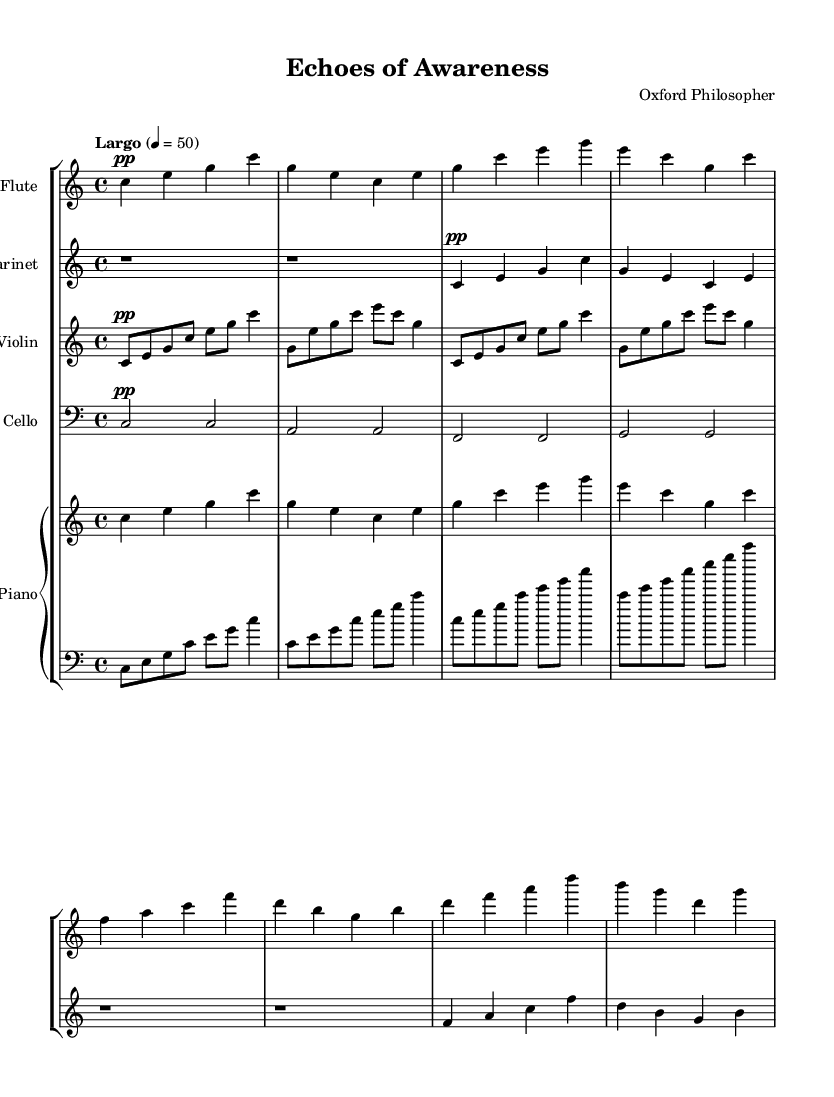What is the key signature of this music? The key signature is C major, which has no sharps or flats.
Answer: C major What is the time signature of this composition? The time signature is indicated at the beginning of the staff as 4/4, meaning there are four beats in each measure and a quarter note gets one beat.
Answer: 4/4 What is the tempo marking of this symphony? The tempo marking shows "Largo," which indicates a slow tempo, typically around 40 to 60 beats per minute. The specific marking states "4 = 50" which tells us the chosen tempo within that range.
Answer: Largo Which instruments are featured in this composition? The instruments included are Flute, Clarinet, Violin, Cello, and Piano (both upper and lower). The score explicitly states each instrument and groups them accordingly.
Answer: Flute, Clarinet, Violin, Cello, Piano What characteristic of minimalism is reflected in the use of dynamics throughout the piece? The piece predominantly uses soft dynamics (pp), which is typical in minimalist compositions, creating a sense of calm and allowing the listener to reflect on the sound spaces and layers involved. The dynamics help in emphasizing the nature of consciousness and perception.
Answer: Soft dynamics What is unique about the rhythmic structure of the violin part? The violin part has a repetitive structure with consistent subdivisions, which is a hallmark of minimalist music. It maintains a focus on the same pitches, emphasizing the simplicity and continuity often found in minimalist compositions.
Answer: Repetitive structure 